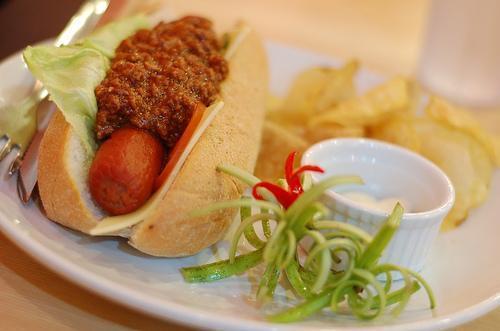How many forks can you see?
Give a very brief answer. 1. How many cups are visible?
Give a very brief answer. 2. How many motorcycles are in the scene?
Give a very brief answer. 0. 